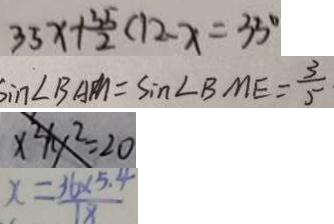<formula> <loc_0><loc_0><loc_500><loc_500>3 5 x + \frac { 3 5 } { 2 } ( 1 2 - x = 3 5 ^ { \circ } 
 \sin \angle B A M = \sin \angle B M E = \frac { 3 } { 5 } 
 x ^ { 2 } + y ^ { 2 } = 2 0 
 x = \frac { 3 6 \times 5 . 4 } { 1 8 }</formula> 